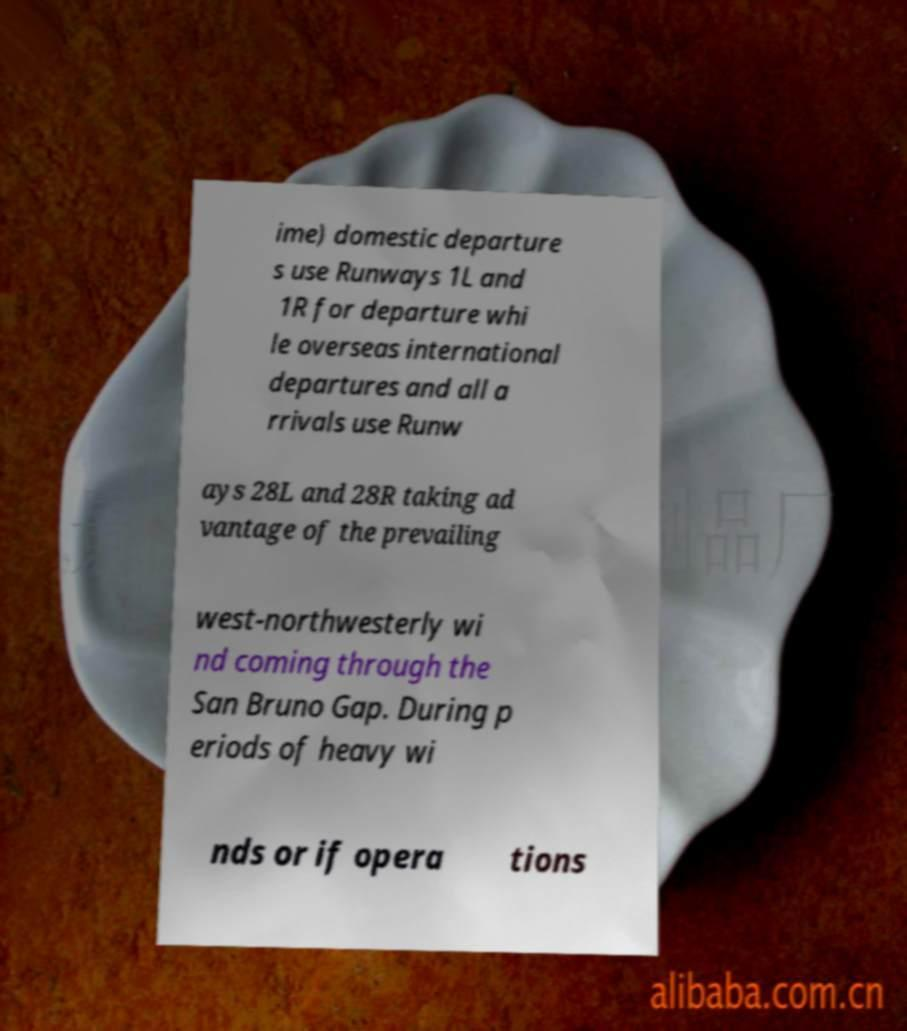For documentation purposes, I need the text within this image transcribed. Could you provide that? ime) domestic departure s use Runways 1L and 1R for departure whi le overseas international departures and all a rrivals use Runw ays 28L and 28R taking ad vantage of the prevailing west-northwesterly wi nd coming through the San Bruno Gap. During p eriods of heavy wi nds or if opera tions 